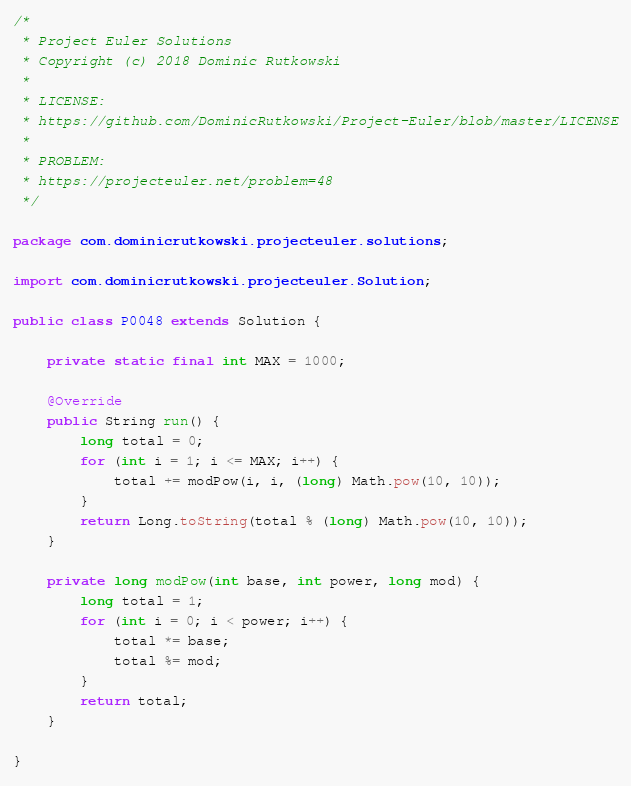Convert code to text. <code><loc_0><loc_0><loc_500><loc_500><_Java_>/*
 * Project Euler Solutions
 * Copyright (c) 2018 Dominic Rutkowski
 *
 * LICENSE:
 * https://github.com/DominicRutkowski/Project-Euler/blob/master/LICENSE
 *
 * PROBLEM:
 * https://projecteuler.net/problem=48
 */

package com.dominicrutkowski.projecteuler.solutions;

import com.dominicrutkowski.projecteuler.Solution;

public class P0048 extends Solution {

    private static final int MAX = 1000;

    @Override
    public String run() {
        long total = 0;
        for (int i = 1; i <= MAX; i++) {
            total += modPow(i, i, (long) Math.pow(10, 10));
        }
        return Long.toString(total % (long) Math.pow(10, 10));
    }

    private long modPow(int base, int power, long mod) {
        long total = 1;
        for (int i = 0; i < power; i++) {
            total *= base;
            total %= mod;
        }
        return total;
    }

}
</code> 